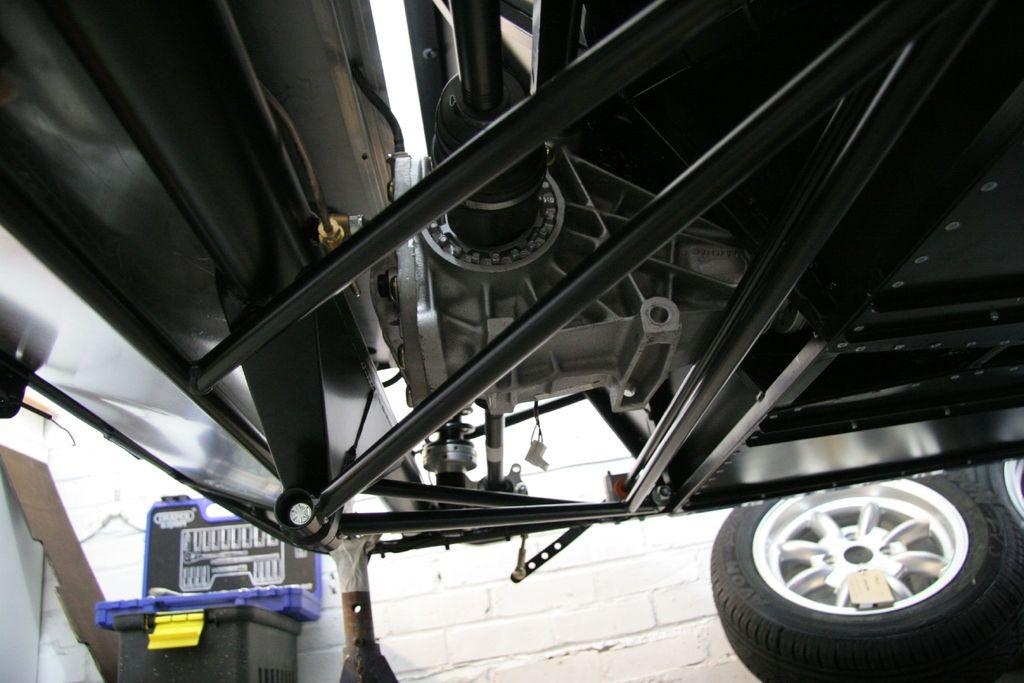What type of object is present in the image that has wheels? There is a vehicle in the image that has wheels. What is on the vehicle? There is a box on the vehicle. What is located behind the vehicle in the image? There is a wall in the image. What can be seen on the wall? There is text on the wall. What type of skirt is hanging on the wall in the image? There is no skirt present in the image; the wall features text instead. 